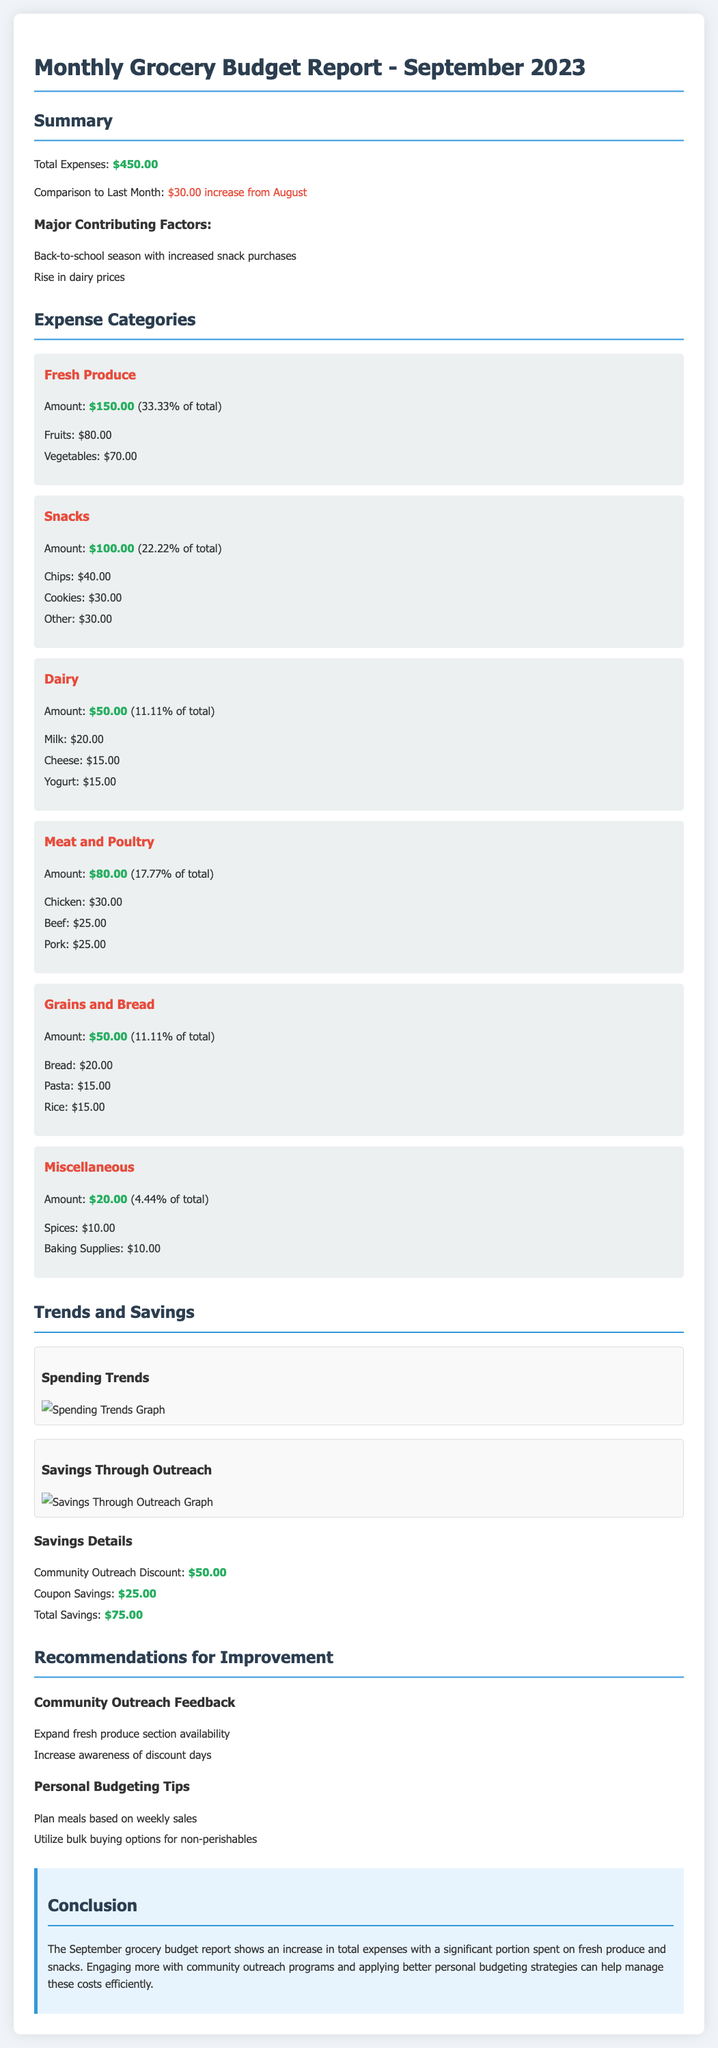What are the total expenses for September 2023? The total expenses are listed in the summary section of the document.
Answer: $450.00 What is the increase in expenses compared to last month? The comparison to last month is provided in the summary section, indicating the change in expenses.
Answer: $30.00 increase from August What percentage of total expenses was spent on fresh produce? The percentage spent on fresh produce is calculated in relation to the total expenses, as mentioned in the categories section.
Answer: 33.33% of total How much did the community outreach discount save? The savings from the community outreach discount is stated in the savings details section of the trends.
Answer: $50.00 What is the primary reason for the increase in expenses? The major contributing factors for the expense increase are provided in the summary section, listing reasons for spending.
Answer: Back-to-school season What amount was spent on snacks? The amount spent on snacks is indicated in the categories section, detailing expenditures by item type.
Answer: $100.00 How much did the coupons save in total? The total savings from coupons is provided in the savings details section of the trends.
Answer: $25.00 What is one recommendation for community outreach improvement? The recommendations section provides suggestions for improving the community outreach program.
Answer: Expand fresh produce section availability What item category received the least spending? The spending details for each item category are listed, from which the category with the least spending can be identified.
Answer: Miscellaneous 